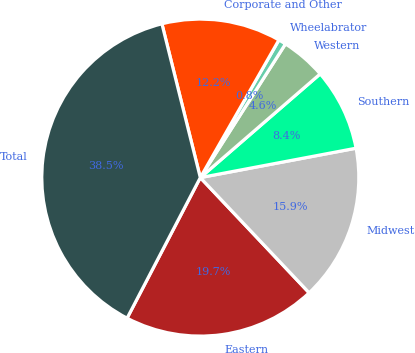Convert chart. <chart><loc_0><loc_0><loc_500><loc_500><pie_chart><fcel>Eastern<fcel>Midwest<fcel>Southern<fcel>Western<fcel>Wheelabrator<fcel>Corporate and Other<fcel>Total<nl><fcel>19.69%<fcel>15.92%<fcel>8.38%<fcel>4.62%<fcel>0.77%<fcel>12.15%<fcel>38.46%<nl></chart> 